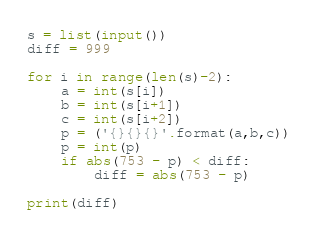Convert code to text. <code><loc_0><loc_0><loc_500><loc_500><_Python_>s = list(input())
diff = 999

for i in range(len(s)-2):
    a = int(s[i])
    b = int(s[i+1])
    c = int(s[i+2])
    p = ('{}{}{}'.format(a,b,c))
    p = int(p)
    if abs(753 - p) < diff:
        diff = abs(753 - p)

print(diff)</code> 